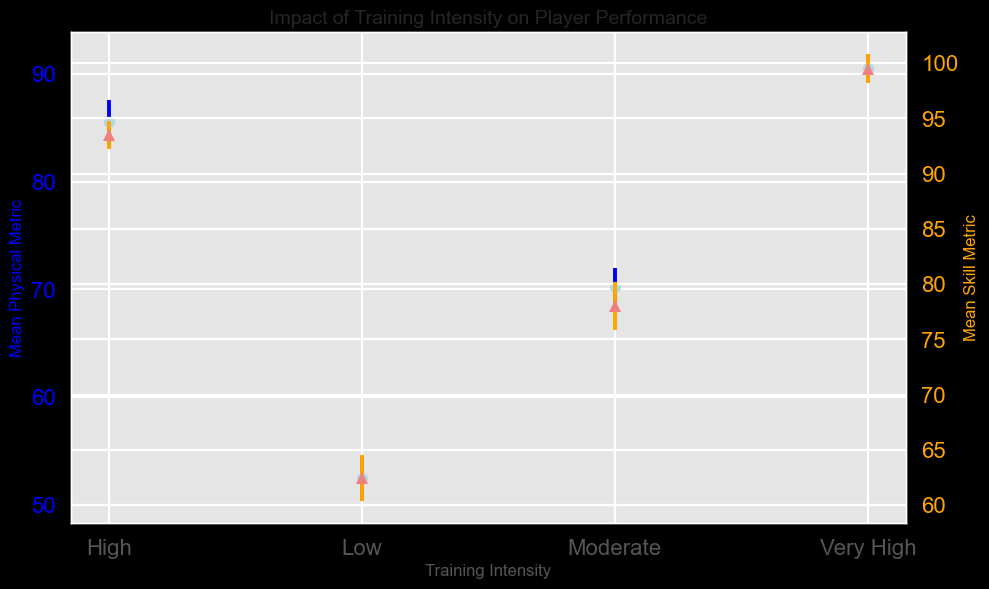What is the training intensity level with the highest mean skill metric? The figure shows that the 'Very High' training intensity level has the highest mean skill metric, indicated by the highest point of the orange "^" markers on the right Y-axis.
Answer: Very High Between 'Moderate' and 'High' training intensity, which one has a higher mean physical metric? By comparing the mean physical metrics for 'Moderate' and 'High' training intensities, it is clear that the 'High' training intensity has a higher mean physical metric as shown by the blue "o" markers on the left Y-axis.
Answer: High What is the mean skill metric for 'Very High' training intensity? The mean skill metric for 'Very High' training intensity can be observed at around 99-100, as represented by the highest orange "^" marker.
Answer: Approximately 99-100 How do the standard deviations of physical metrics for 'High' and 'Very High' training intensities compare? The standard deviations are represented by the error bars. 'High' training intensity has a slightly smaller standard deviation in the physical metric compared to the 'Very High' training intensity, as seen from the shorter blue error bars.
Answer: 'High' has a smaller standard deviation At what training intensity do we see the largest variance in the skill metric? The largest variance (standard deviation) in the skill metric is indicated by the longest orange error bars, which occur at the 'Very High' training intensity.
Answer: Very High What is the mean physical metric for 'Low' training intensity? The mean physical metric for 'Low' training intensity is around 52-53, as indicated by the first set of blue "o" markers.
Answer: Approximately 52-53 Is the mean skill metric for 'Moderate' training intensity greater than 75? Checking the orange "^" marker for 'Moderate' training intensity, it can be observed that the mean skill metric is slightly above 75.
Answer: Yes Which training intensity shows the smallest spread (variance) in physical metrics? The smallest spread in physical metrics is shown by the shortest blue error bars, which occur at the 'High' training intensity.
Answer: High How does the mean physical metric of 'Very High' training intensity compare to 'Low' training intensity? The mean physical metric for 'Very High' training intensity is significantly higher than that of 'Low' training intensity, indicated by the much higher position of the blue "o" marker for 'Very High'.
Answer: 'Very High' is higher What is the combined mean physical metric for 'Moderate' and 'High' training intensities? Adding the mean physical metrics for 'Moderate' (around 70-72) and 'High' (around 85-86), and dividing by 2 gives the combined mean: (70 + 85) / 2 = 77.5.
Answer: Approximately 77.5 Is the mean skill metric for 'High' training intensity less than the mean skill metric for 'Very High' training intensity? Yes, the mean skill metric for 'High' training intensity is less than that of 'Very High', as the orange "^" marker for 'Very High' lies above the one for 'High'.
Answer: Yes 